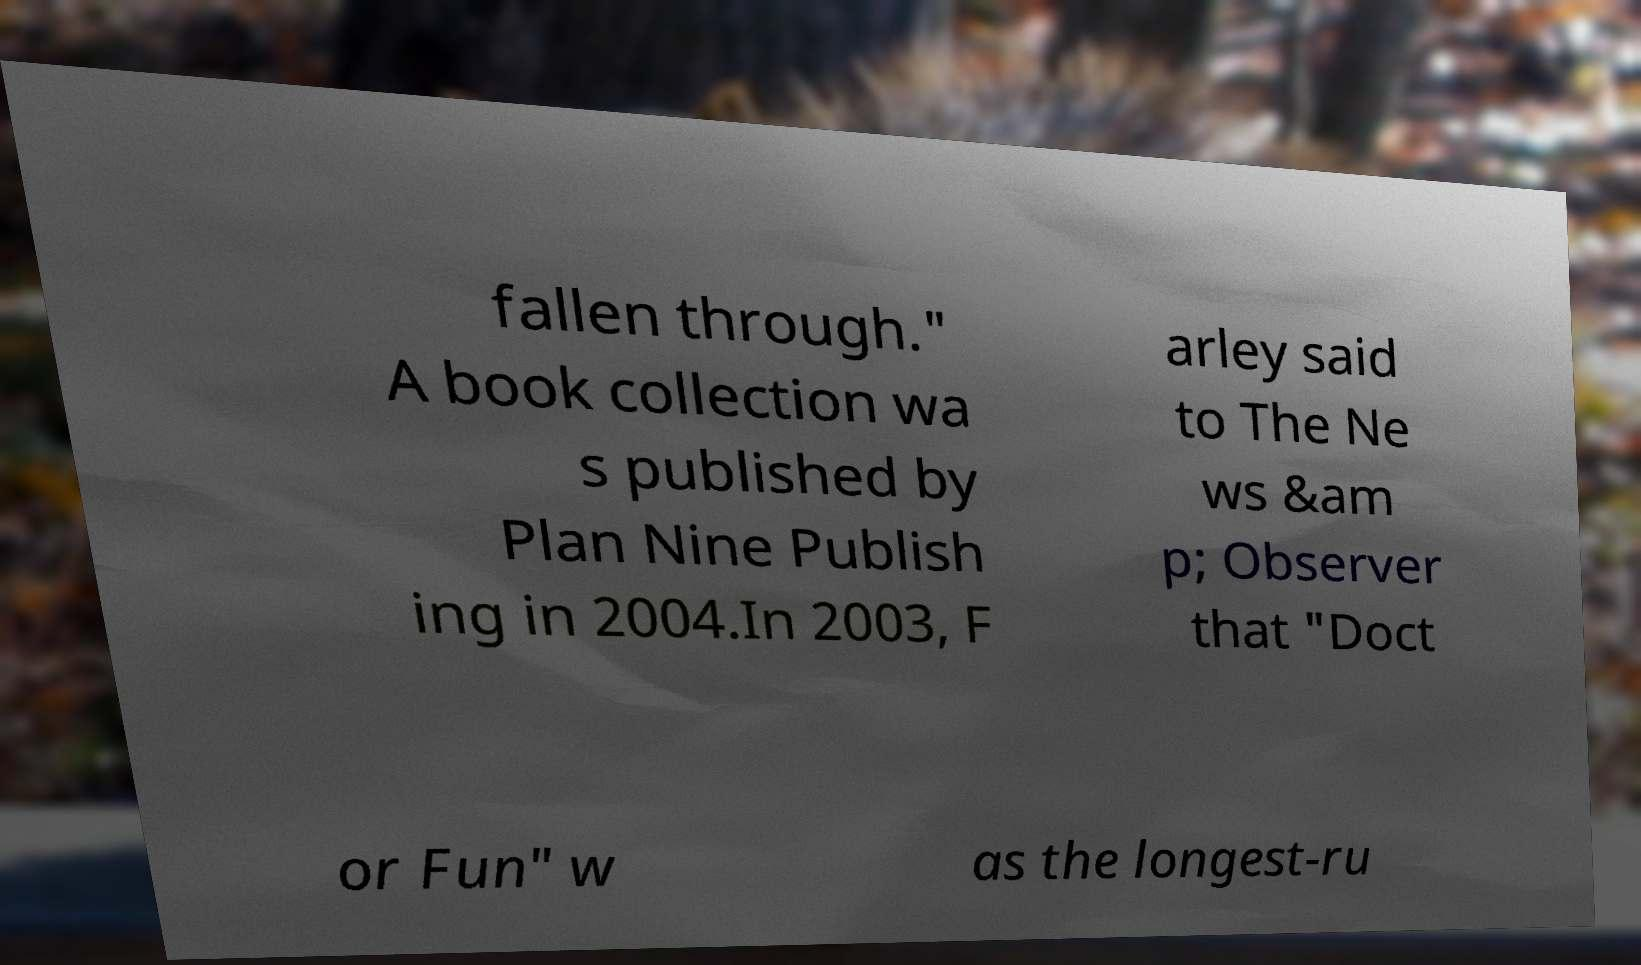Could you assist in decoding the text presented in this image and type it out clearly? fallen through." A book collection wa s published by Plan Nine Publish ing in 2004.In 2003, F arley said to The Ne ws &am p; Observer that "Doct or Fun" w as the longest-ru 